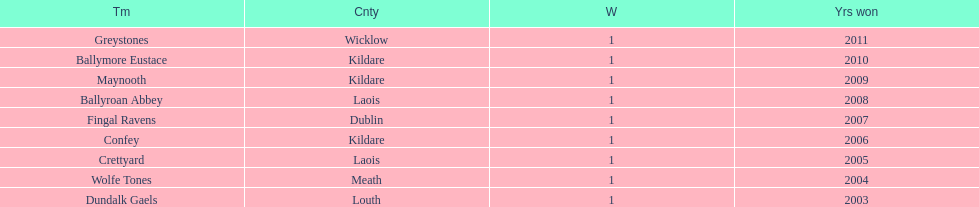What is the total of triumphs for each team? 1. 